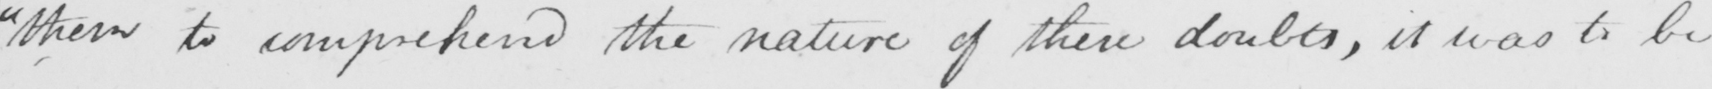What does this handwritten line say? " them to comprehend the nature of these doubts , it was to be 